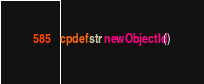<code> <loc_0><loc_0><loc_500><loc_500><_Cython_>cpdef str newObjectId()</code> 